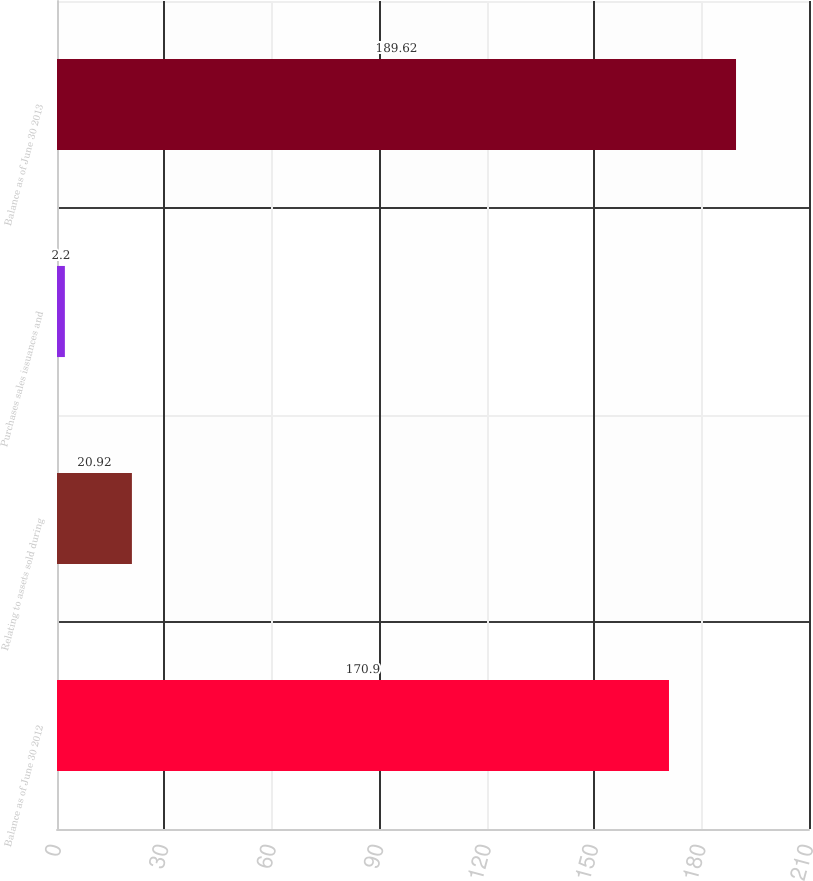Convert chart. <chart><loc_0><loc_0><loc_500><loc_500><bar_chart><fcel>Balance as of June 30 2012<fcel>Relating to assets sold during<fcel>Purchases sales issuances and<fcel>Balance as of June 30 2013<nl><fcel>170.9<fcel>20.92<fcel>2.2<fcel>189.62<nl></chart> 